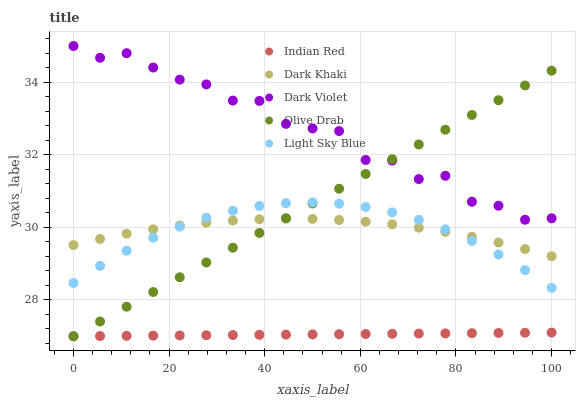Does Indian Red have the minimum area under the curve?
Answer yes or no. Yes. Does Dark Violet have the maximum area under the curve?
Answer yes or no. Yes. Does Olive Drab have the minimum area under the curve?
Answer yes or no. No. Does Olive Drab have the maximum area under the curve?
Answer yes or no. No. Is Indian Red the smoothest?
Answer yes or no. Yes. Is Dark Violet the roughest?
Answer yes or no. Yes. Is Olive Drab the smoothest?
Answer yes or no. No. Is Olive Drab the roughest?
Answer yes or no. No. Does Olive Drab have the lowest value?
Answer yes or no. Yes. Does Light Sky Blue have the lowest value?
Answer yes or no. No. Does Dark Violet have the highest value?
Answer yes or no. Yes. Does Olive Drab have the highest value?
Answer yes or no. No. Is Indian Red less than Dark Khaki?
Answer yes or no. Yes. Is Dark Khaki greater than Indian Red?
Answer yes or no. Yes. Does Dark Khaki intersect Light Sky Blue?
Answer yes or no. Yes. Is Dark Khaki less than Light Sky Blue?
Answer yes or no. No. Is Dark Khaki greater than Light Sky Blue?
Answer yes or no. No. Does Indian Red intersect Dark Khaki?
Answer yes or no. No. 